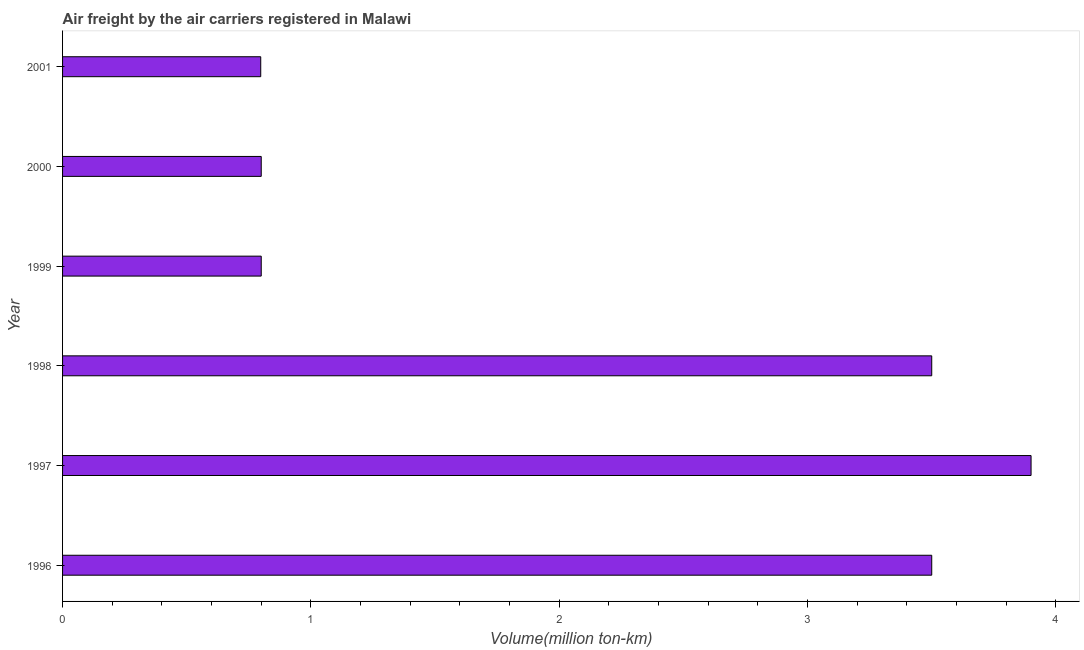What is the title of the graph?
Your response must be concise. Air freight by the air carriers registered in Malawi. What is the label or title of the X-axis?
Ensure brevity in your answer.  Volume(million ton-km). What is the label or title of the Y-axis?
Provide a short and direct response. Year. What is the air freight in 1998?
Provide a succinct answer. 3.5. Across all years, what is the maximum air freight?
Ensure brevity in your answer.  3.9. Across all years, what is the minimum air freight?
Provide a short and direct response. 0.8. In which year was the air freight maximum?
Provide a succinct answer. 1997. In which year was the air freight minimum?
Your response must be concise. 2001. What is the sum of the air freight?
Your answer should be very brief. 13.3. What is the difference between the air freight in 1997 and 2001?
Offer a terse response. 3.1. What is the average air freight per year?
Your answer should be compact. 2.22. What is the median air freight?
Make the answer very short. 2.15. Do a majority of the years between 2000 and 1996 (inclusive) have air freight greater than 0.8 million ton-km?
Provide a succinct answer. Yes. What is the ratio of the air freight in 1999 to that in 2000?
Provide a short and direct response. 1. Is the air freight in 1997 less than that in 2001?
Give a very brief answer. No. Is the difference between the air freight in 1996 and 1997 greater than the difference between any two years?
Your response must be concise. No. What is the difference between the highest and the second highest air freight?
Make the answer very short. 0.4. Is the sum of the air freight in 1997 and 2000 greater than the maximum air freight across all years?
Offer a very short reply. Yes. What is the difference between the highest and the lowest air freight?
Offer a very short reply. 3.1. In how many years, is the air freight greater than the average air freight taken over all years?
Provide a short and direct response. 3. Are all the bars in the graph horizontal?
Ensure brevity in your answer.  Yes. Are the values on the major ticks of X-axis written in scientific E-notation?
Keep it short and to the point. No. What is the Volume(million ton-km) in 1997?
Your response must be concise. 3.9. What is the Volume(million ton-km) in 1999?
Keep it short and to the point. 0.8. What is the Volume(million ton-km) of 2000?
Your response must be concise. 0.8. What is the Volume(million ton-km) of 2001?
Provide a succinct answer. 0.8. What is the difference between the Volume(million ton-km) in 1996 and 1999?
Keep it short and to the point. 2.7. What is the difference between the Volume(million ton-km) in 1996 and 2000?
Make the answer very short. 2.7. What is the difference between the Volume(million ton-km) in 1996 and 2001?
Provide a succinct answer. 2.7. What is the difference between the Volume(million ton-km) in 1997 and 1999?
Your response must be concise. 3.1. What is the difference between the Volume(million ton-km) in 1997 and 2000?
Ensure brevity in your answer.  3.1. What is the difference between the Volume(million ton-km) in 1997 and 2001?
Your response must be concise. 3.1. What is the difference between the Volume(million ton-km) in 1998 and 2001?
Your response must be concise. 2.7. What is the difference between the Volume(million ton-km) in 1999 and 2001?
Offer a very short reply. 0. What is the difference between the Volume(million ton-km) in 2000 and 2001?
Provide a succinct answer. 0. What is the ratio of the Volume(million ton-km) in 1996 to that in 1997?
Offer a very short reply. 0.9. What is the ratio of the Volume(million ton-km) in 1996 to that in 1998?
Offer a very short reply. 1. What is the ratio of the Volume(million ton-km) in 1996 to that in 1999?
Your response must be concise. 4.38. What is the ratio of the Volume(million ton-km) in 1996 to that in 2000?
Make the answer very short. 4.38. What is the ratio of the Volume(million ton-km) in 1996 to that in 2001?
Ensure brevity in your answer.  4.39. What is the ratio of the Volume(million ton-km) in 1997 to that in 1998?
Keep it short and to the point. 1.11. What is the ratio of the Volume(million ton-km) in 1997 to that in 1999?
Give a very brief answer. 4.88. What is the ratio of the Volume(million ton-km) in 1997 to that in 2000?
Keep it short and to the point. 4.88. What is the ratio of the Volume(million ton-km) in 1997 to that in 2001?
Provide a succinct answer. 4.89. What is the ratio of the Volume(million ton-km) in 1998 to that in 1999?
Your response must be concise. 4.38. What is the ratio of the Volume(million ton-km) in 1998 to that in 2000?
Ensure brevity in your answer.  4.38. What is the ratio of the Volume(million ton-km) in 1998 to that in 2001?
Ensure brevity in your answer.  4.39. What is the ratio of the Volume(million ton-km) in 1999 to that in 2000?
Offer a very short reply. 1. What is the ratio of the Volume(million ton-km) in 1999 to that in 2001?
Your answer should be very brief. 1. What is the ratio of the Volume(million ton-km) in 2000 to that in 2001?
Make the answer very short. 1. 